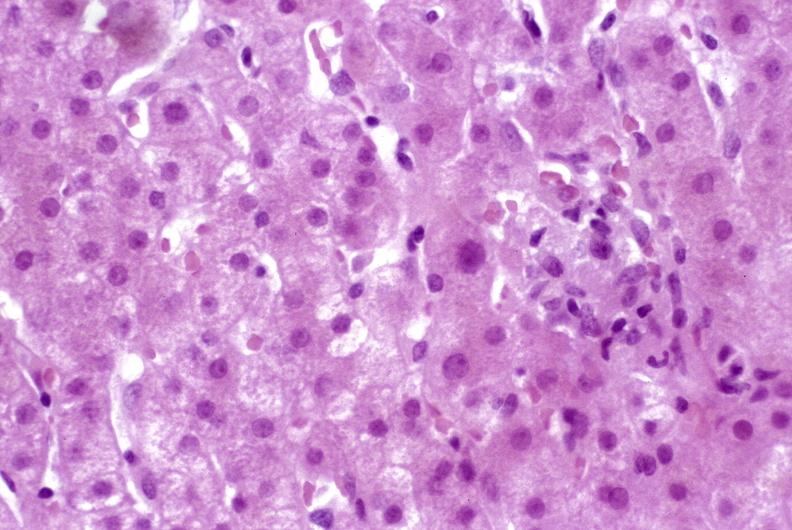s liver present?
Answer the question using a single word or phrase. Yes 